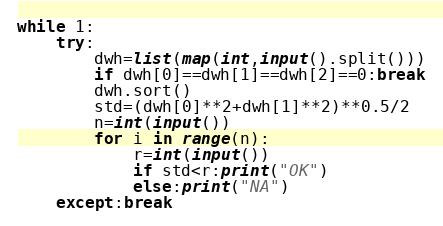<code> <loc_0><loc_0><loc_500><loc_500><_Python_>while 1:
    try:
        dwh=list(map(int,input().split()))
        if dwh[0]==dwh[1]==dwh[2]==0:break
        dwh.sort()
        std=(dwh[0]**2+dwh[1]**2)**0.5/2
        n=int(input())
        for i in range(n):
            r=int(input())
            if std<r:print("OK")
            else:print("NA")
    except:break
</code> 